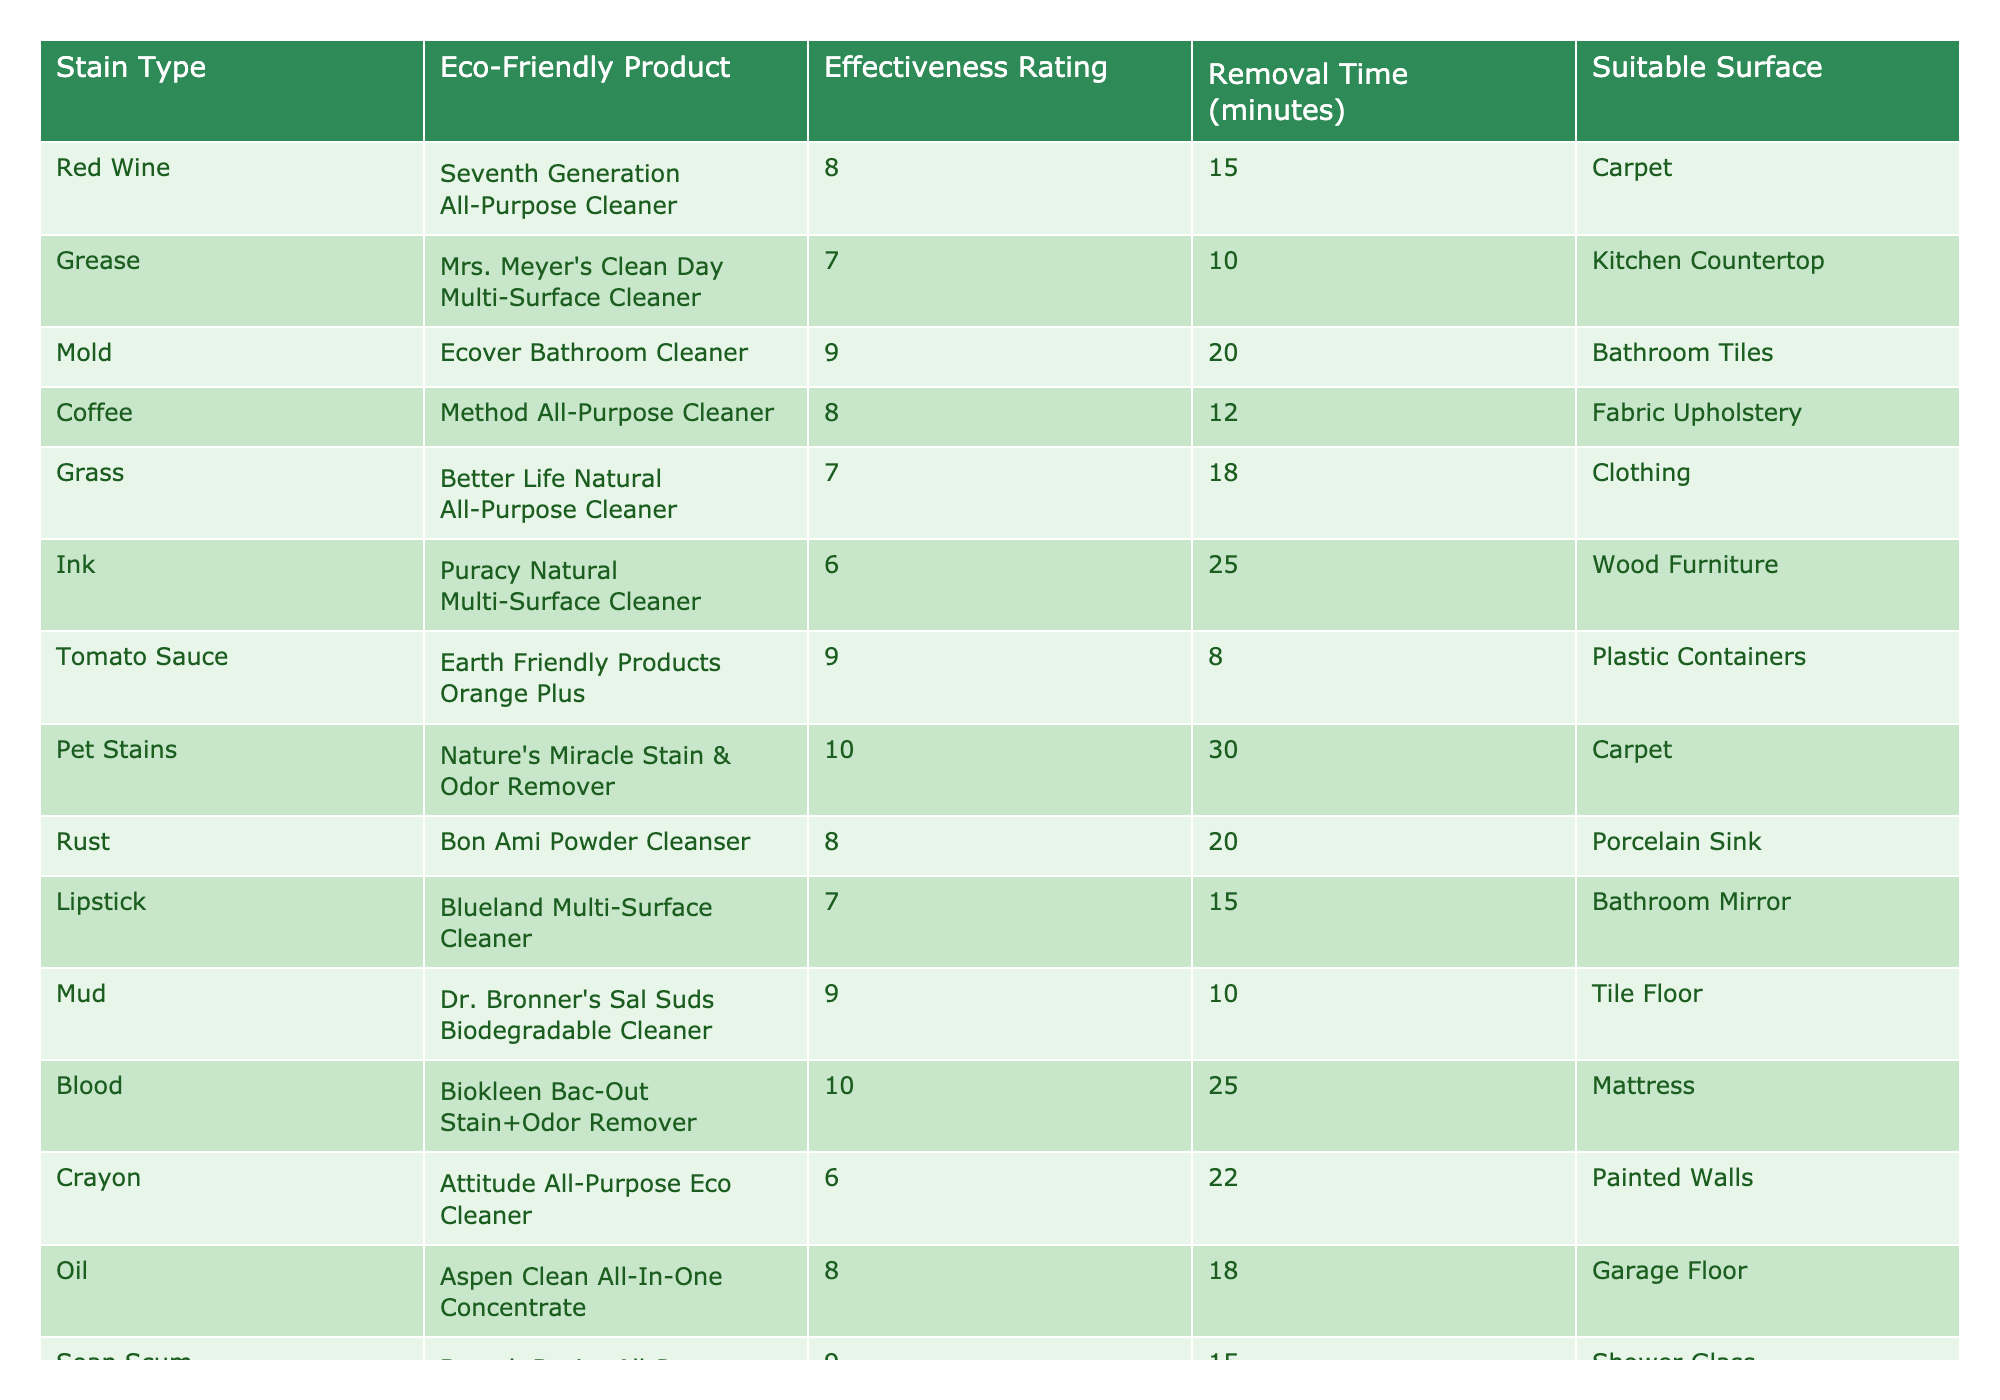What is the effectiveness rating of the product used for removing pet stains? The table indicates that "Nature's Miracle Stain & Odor Remover" is used for pet stains and its effectiveness rating is 10.
Answer: 10 Which stain type has the highest effectiveness rating among the eco-friendly products? According to the table, the highest effectiveness rating of 10 is for both "Nature's Miracle Stain & Odor Remover" (pet stains) and "Biokleen Bac-Out Stain+Odor Remover" (blood).
Answer: Pet stains and blood How many minutes does it take to remove coffee stains using eco-friendly products? The table shows that "Method All-Purpose Cleaner" is used for coffee stains and the removal time is 12 minutes.
Answer: 12 minutes What is the average effectiveness rating of the cleaning products listed for stain removal? Adding the effectiveness ratings: (8 + 7 + 9 + 8 + 7 + 6 + 9 + 10 + 8 + 7 + 9 + 10 + 6 + 8 + 9) = 137. The total number of products is 15. Thus, the average effectiveness rating is 137 / 15 ≈ 9.13.
Answer: Approximately 9.13 Is the product "Blueland Multi-Surface Cleaner" suitable for removing mud stains? The table indicates that "Blueland Multi-Surface Cleaner" is used for removing lipstick stains, not mud. Therefore, it is not suitable for removing mud stains.
Answer: No Which cleaning product takes the longest time to remove a stain? "Nature's Miracle Stain & Odor Remover" takes 30 minutes to remove pet stains, which is the longest time compared to other products listed in the table.
Answer: 30 minutes How many products have an effectiveness rating of 9 or higher? By examining the table, the cleaning products with an effectiveness rating of 9 or higher are: "Mold" (9), "Tomato Sauce" (9), "Mud" (9), "Soap Scum" (9), "Blood" (10), and "Pet Stains" (10). Counting these gives a total of 6 products.
Answer: 6 products Which stain types are suitable for carpet cleaning? The table lists "Red Wine" and "Pet Stains" as suitable for carpet cleaning. Thus, both stain types can be addressed with eco-friendly products designed for carpets.
Answer: Red Wine and Pet Stains What product is used for cleaning ink stains and how effective is it? "Puracy Natural Multi-Surface Cleaner" is the product used for ink stains and its effectiveness rating is 6.
Answer: 6 Are any eco-friendly cleaning products rated below 7 in effectiveness? Yes, the "Puracy Natural Multi-Surface Cleaner" for ink stains has an effectiveness rating of 6 and "Attitude All-Purpose Eco Cleaner" for crayon stains also has a rating of 6.
Answer: Yes 